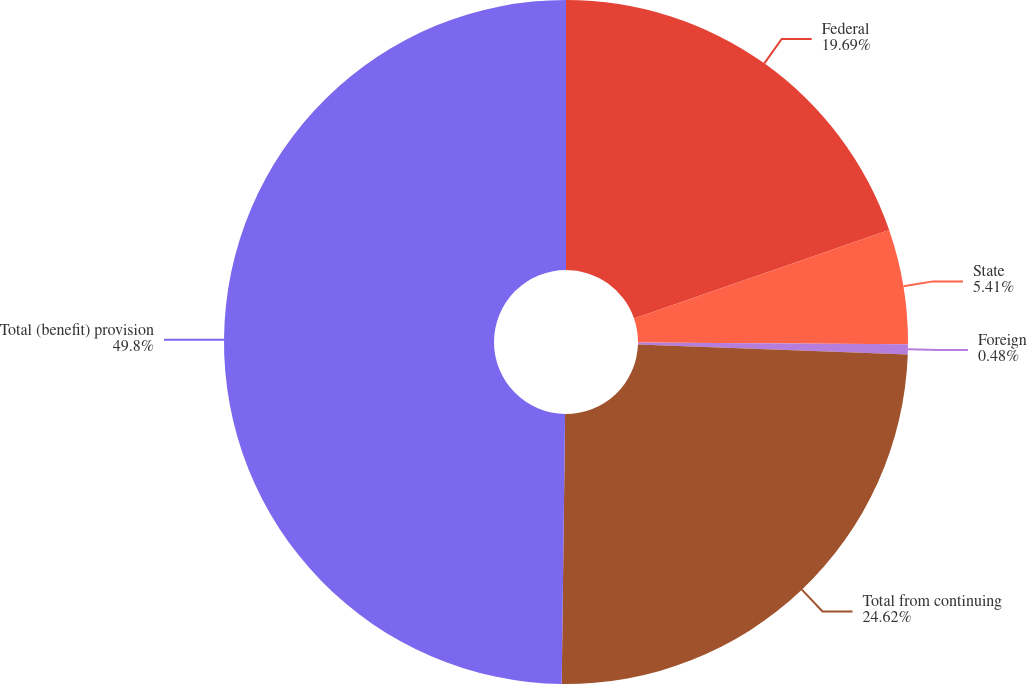Convert chart to OTSL. <chart><loc_0><loc_0><loc_500><loc_500><pie_chart><fcel>Federal<fcel>State<fcel>Foreign<fcel>Total from continuing<fcel>Total (benefit) provision<nl><fcel>19.69%<fcel>5.41%<fcel>0.48%<fcel>24.62%<fcel>49.8%<nl></chart> 